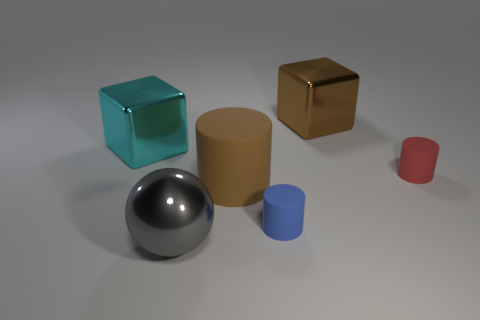Subtract all small cylinders. How many cylinders are left? 1 Add 1 large brown shiny spheres. How many objects exist? 7 Subtract all yellow cylinders. Subtract all purple blocks. How many cylinders are left? 3 Subtract all spheres. How many objects are left? 5 Subtract all tiny blue shiny cylinders. Subtract all large gray balls. How many objects are left? 5 Add 4 large brown matte things. How many large brown matte things are left? 5 Add 5 small blue spheres. How many small blue spheres exist? 5 Subtract 0 green cylinders. How many objects are left? 6 